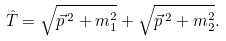Convert formula to latex. <formula><loc_0><loc_0><loc_500><loc_500>\hat { T } = \sqrt { \vec { p } \, ^ { 2 } + m _ { 1 } ^ { 2 } } + \sqrt { \vec { p } \, ^ { 2 } + m _ { 2 } ^ { 2 } } .</formula> 